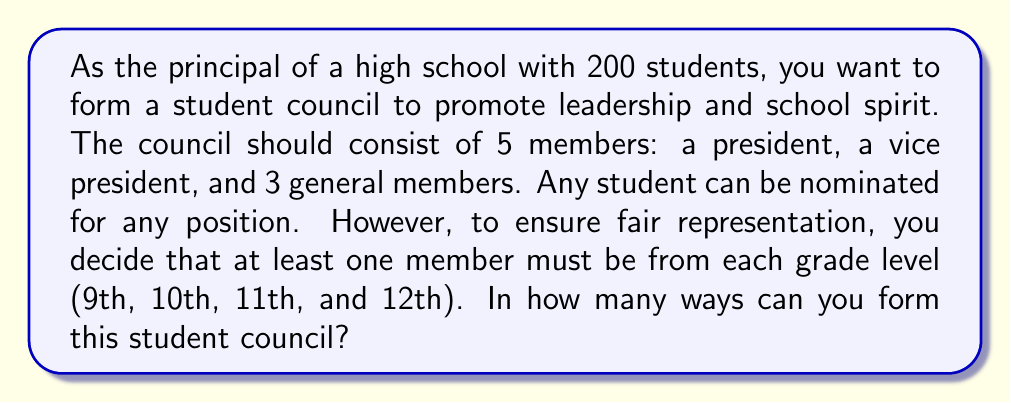Can you solve this math problem? Let's approach this step-by-step:

1) First, we need to choose the president and vice president. This can be done in $200 \times 199 = 39,800$ ways.

2) Now, we need to ensure that all grade levels are represented. Let's consider the grades of the president and vice president:

   a) If they cover 2 different grades, we need to choose 1 student from each of the other 2 grades.
   b) If they cover 1 grade, we need to choose 1 student from each of the other 3 grades.

3) Let's calculate these scenarios:

   Scenario a:
   - Ways to choose 2 grades for president and VP: $\binom{4}{2} = 6$
   - Ways to choose 1 student from each of the other 2 grades: $50 \times 50 = 2,500$
   - Ways to choose the last member from any grade: $200$
   - Total for this scenario: $6 \times 2,500 \times 200 = 3,000,000$

   Scenario b:
   - Ways to choose 1 grade for president and VP: $\binom{4}{1} = 4$
   - Ways to choose 1 student from each of the other 3 grades: $50 \times 50 \times 50 = 125,000$
   - Total for this scenario: $4 \times 125,000 = 500,000$

4) The total number of ways is the sum of these scenarios multiplied by the number of ways to choose the president and vice president:

   $39,800 \times (3,000,000 + 500,000) = 139,300,000,000$

Therefore, there are 139,300,000,000 ways to form the student council.
Answer: $139,300,000,000$ 